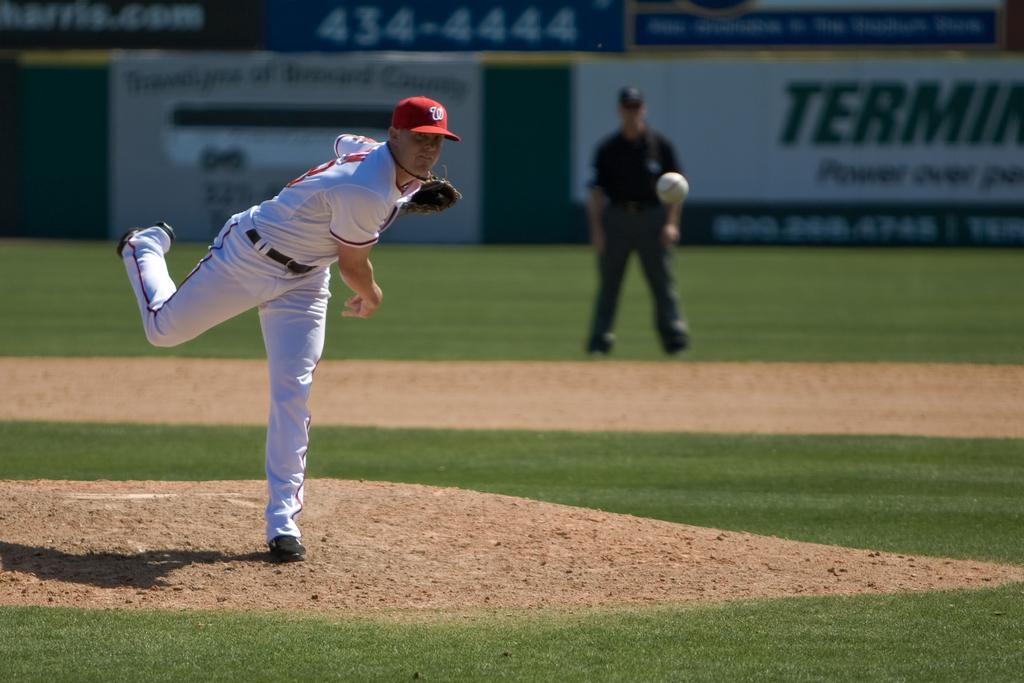<image>
Present a compact description of the photo's key features. A pitcher with a W on his hat leans forward as he finishes his pitch. 